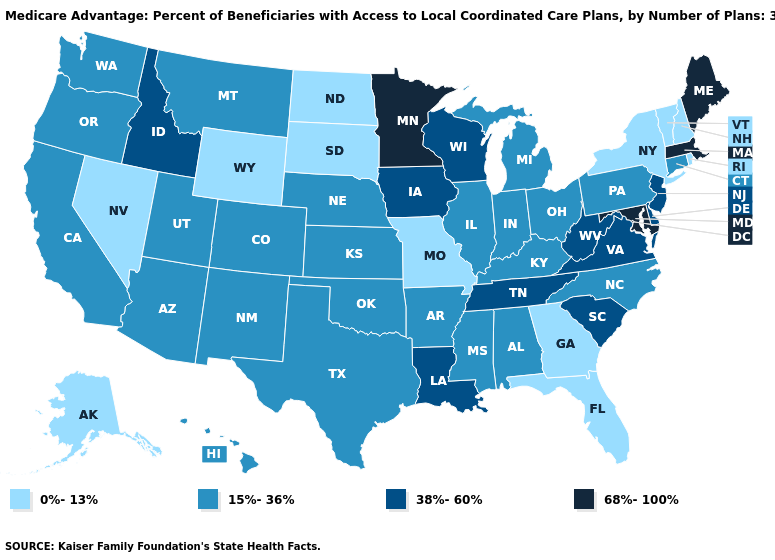Does Massachusetts have the highest value in the USA?
Keep it brief. Yes. Which states have the lowest value in the West?
Answer briefly. Alaska, Nevada, Wyoming. Does Louisiana have the highest value in the USA?
Concise answer only. No. How many symbols are there in the legend?
Quick response, please. 4. Which states have the highest value in the USA?
Answer briefly. Massachusetts, Maryland, Maine, Minnesota. What is the lowest value in the West?
Answer briefly. 0%-13%. Is the legend a continuous bar?
Give a very brief answer. No. Name the states that have a value in the range 38%-60%?
Concise answer only. Delaware, Iowa, Idaho, Louisiana, New Jersey, South Carolina, Tennessee, Virginia, Wisconsin, West Virginia. Does Louisiana have the highest value in the USA?
Be succinct. No. Does Georgia have the highest value in the USA?
Concise answer only. No. What is the value of Oklahoma?
Quick response, please. 15%-36%. Does Nevada have the same value as North Dakota?
Write a very short answer. Yes. Does the first symbol in the legend represent the smallest category?
Quick response, please. Yes. Which states have the lowest value in the USA?
Quick response, please. Alaska, Florida, Georgia, Missouri, North Dakota, New Hampshire, Nevada, New York, Rhode Island, South Dakota, Vermont, Wyoming. Name the states that have a value in the range 0%-13%?
Write a very short answer. Alaska, Florida, Georgia, Missouri, North Dakota, New Hampshire, Nevada, New York, Rhode Island, South Dakota, Vermont, Wyoming. 